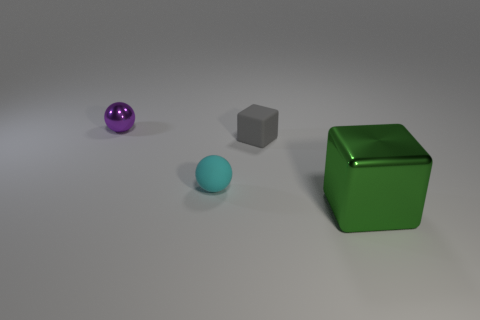Add 2 big purple shiny spheres. How many objects exist? 6 Subtract 1 blocks. How many blocks are left? 1 Add 4 cyan matte balls. How many cyan matte balls exist? 5 Subtract all cyan balls. How many balls are left? 1 Subtract 0 red cylinders. How many objects are left? 4 Subtract all purple spheres. Subtract all brown cubes. How many spheres are left? 1 Subtract all purple cylinders. How many gray blocks are left? 1 Subtract all small red matte spheres. Subtract all matte spheres. How many objects are left? 3 Add 1 tiny matte blocks. How many tiny matte blocks are left? 2 